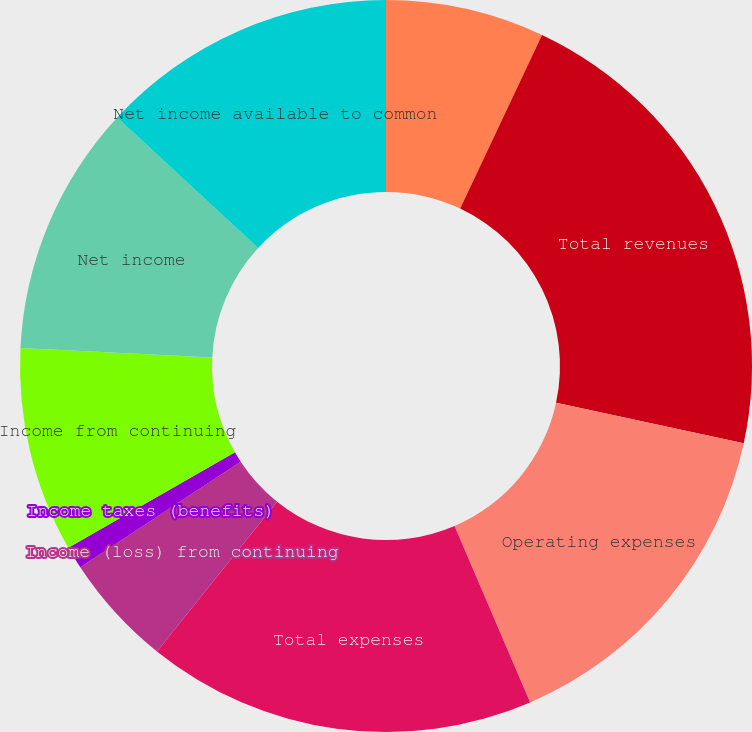<chart> <loc_0><loc_0><loc_500><loc_500><pie_chart><fcel>Net investment income<fcel>Total revenues<fcel>Operating expenses<fcel>Total expenses<fcel>Income (loss) from continuing<fcel>Income taxes (benefits)<fcel>Income from continuing<fcel>Net income<fcel>Net income available to common<nl><fcel>7.01%<fcel>21.38%<fcel>15.17%<fcel>17.21%<fcel>4.97%<fcel>1.0%<fcel>9.05%<fcel>11.09%<fcel>13.13%<nl></chart> 